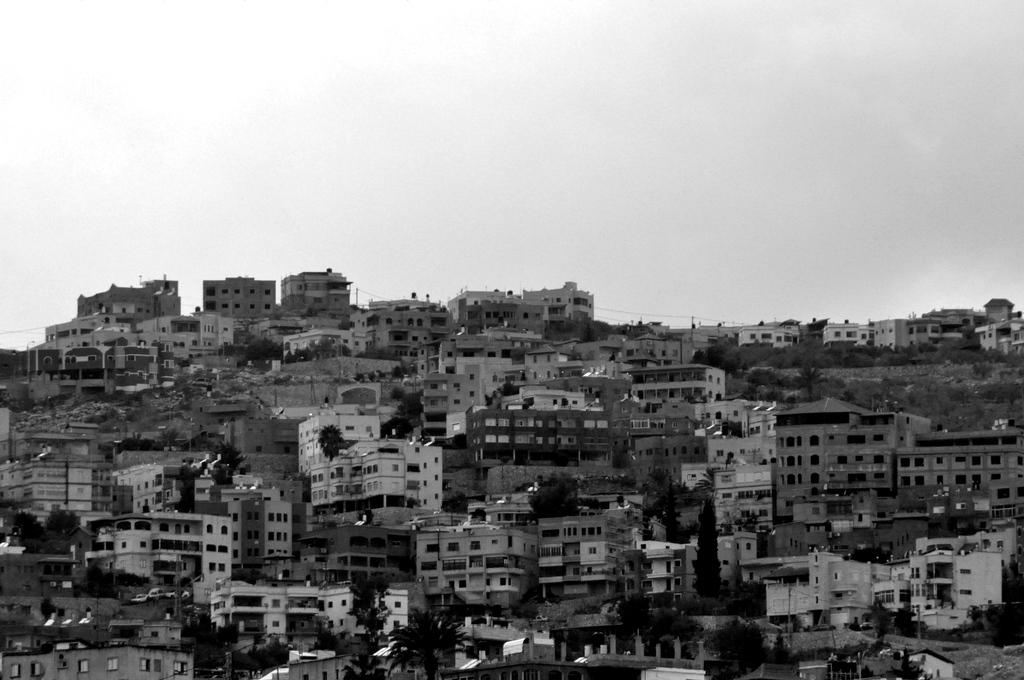What is the color scheme of the image? The image is black and white. What type of structures can be seen in the image? There are buildings in the image. What other natural elements are present in the image? There are trees in the image. What part of the natural environment is visible in the image? The sky is visible in the image. What is the purpose of the basin in the image? There is no basin present in the image. What type of brick is used to construct the buildings in the image? The image is black and white, so it is not possible to determine the type of brick used in the construction of the buildings. 